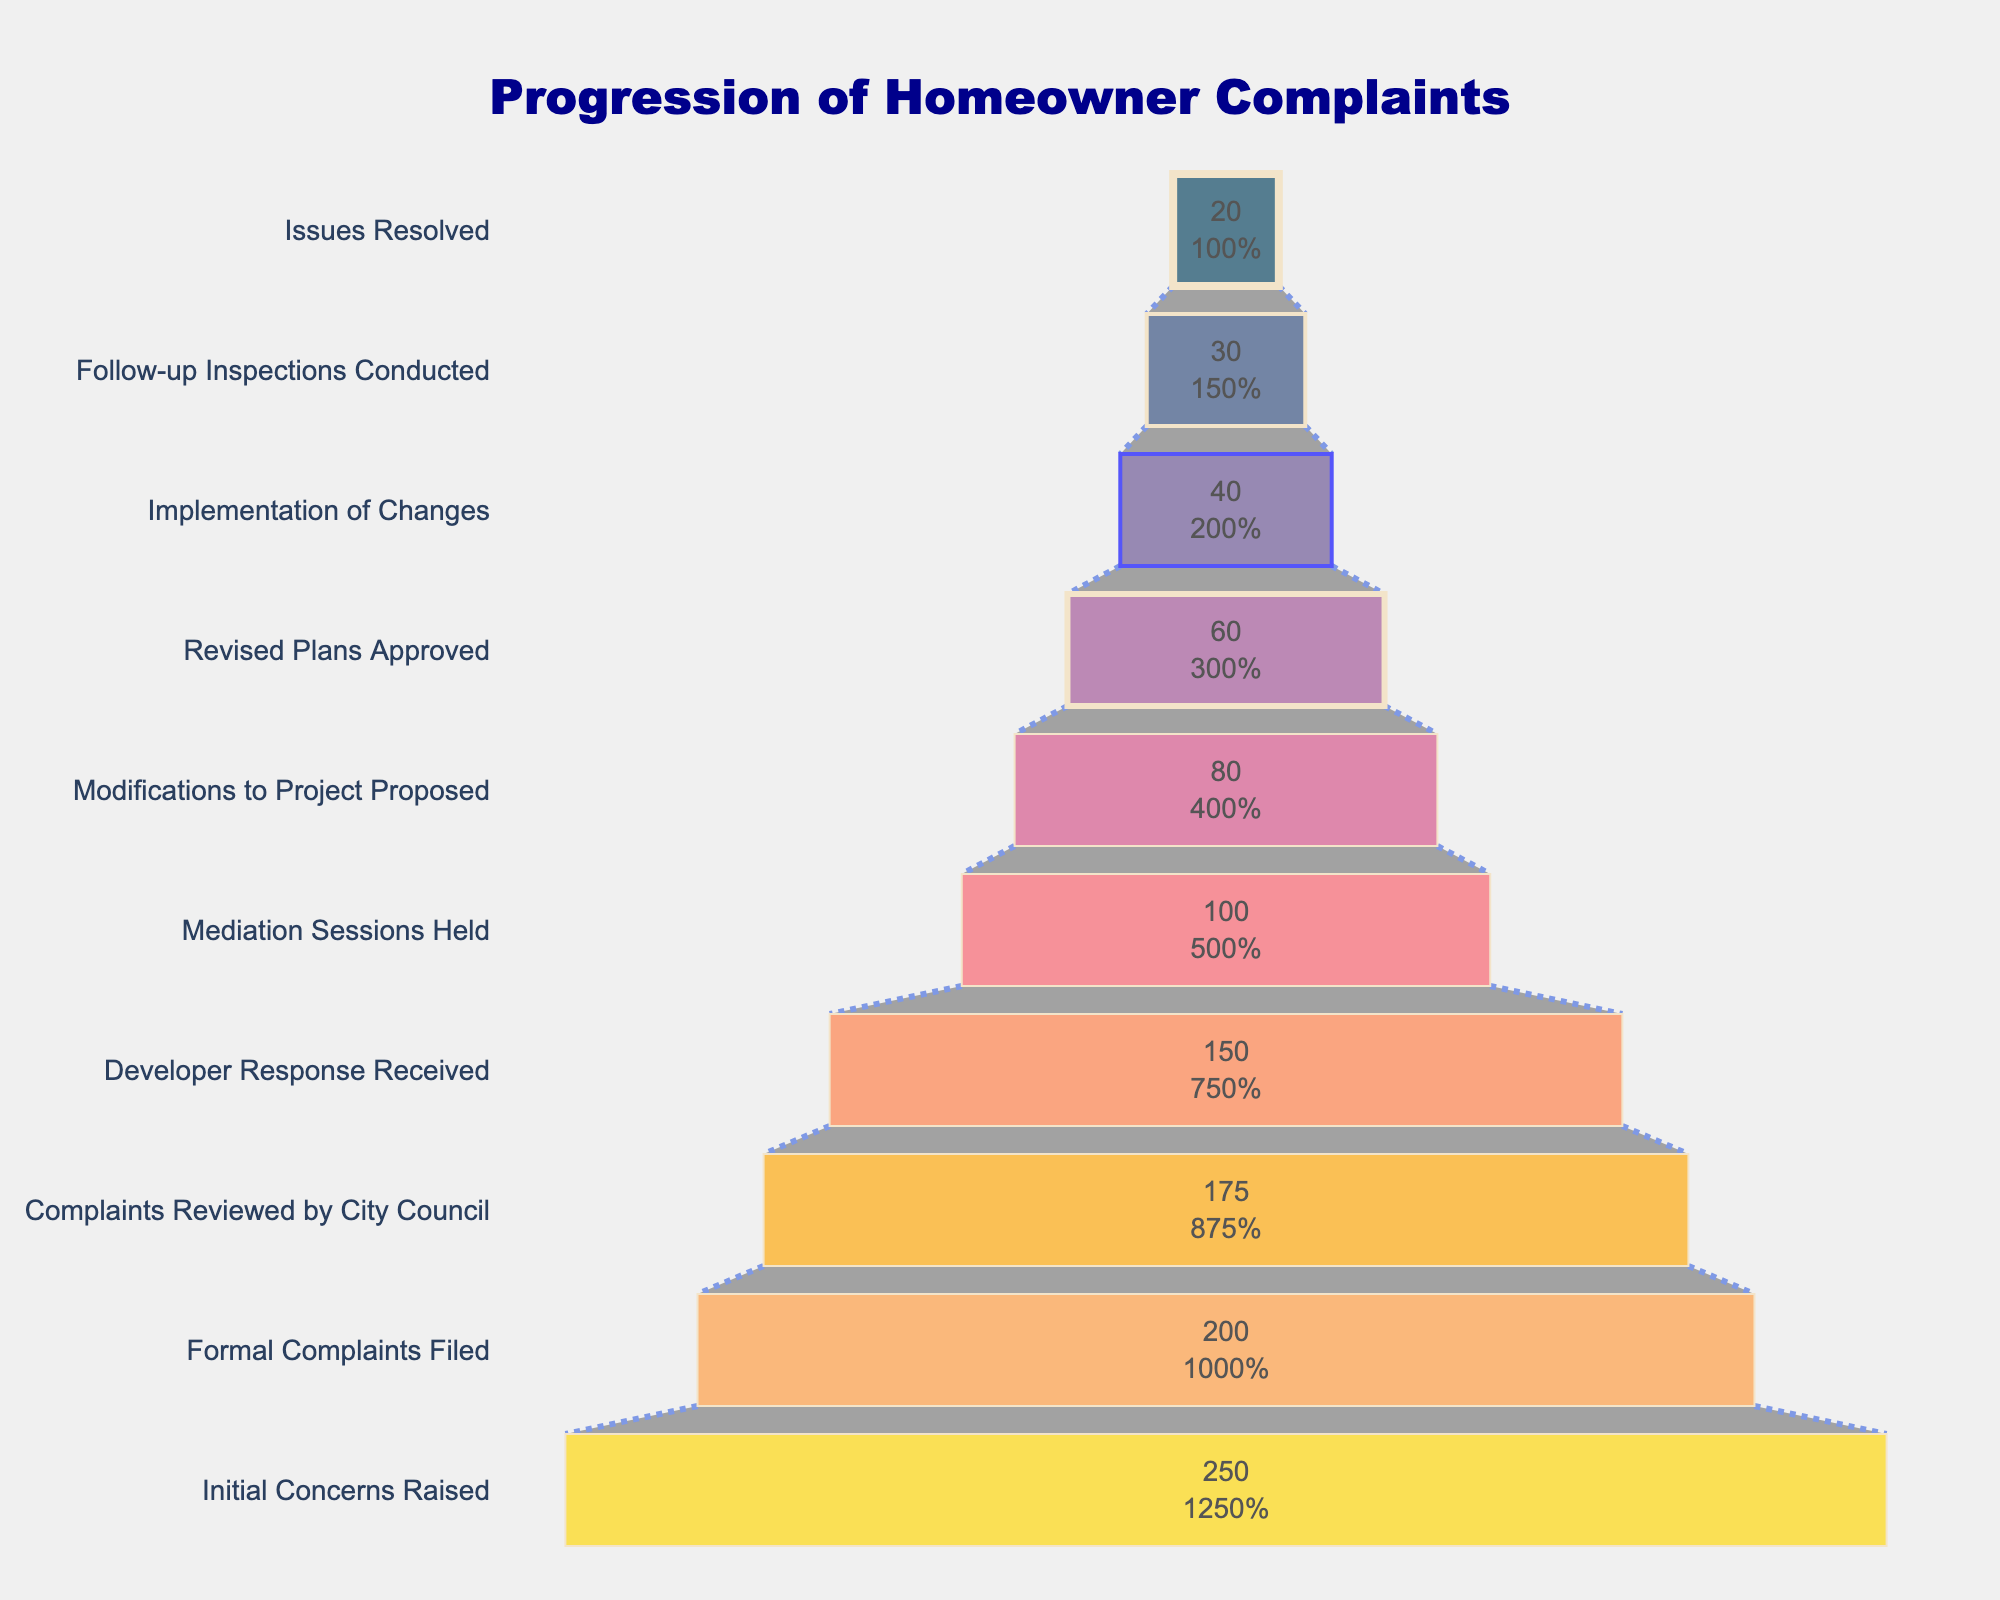How many complaints were initially raised? Look at the first stage in the funnel chart where "Initial Concerns Raised" is displayed and note the number of complaints.
Answer: 250 Which stage has the fewest complaints? Identify the stage on the chart with the smallest value. In this case, the stage "Issues Resolved" has the lowest number.
Answer: Issues Resolved How many complaints were filed formally? Refer to the stage labeled "Formal Complaints Filed" and note the number of complaints associated with it.
Answer: 200 What is the percentage of complaints that reached the "Developer Response Received" stage out of the initial concerns? Divide the number of complaints that reached the "Developer Response Received" stage by the total initial concerns raised and multiply by 100. Calculation: (150/250) * 100 = 60%
Answer: 60% How many more complaints were reviewed by the City Council compared to those that had mediation sessions held? Subtract the complaints at the mediation sessions held stage from those reviewed by the City Council: 175 - 100 = 75.
Answer: 75 What proportion of the complaints were resolved compared to those where modifications to the project were proposed? Divide the number of complaints resolved by those where modifications were proposed and multiply by 100. Calculation: (20/80) * 100 = 25%
Answer: 25% Which stage shows the first instance in the decrease of the number of complaints by more than 50 compared to the previous stage? Check the stages sequentially to see where the number of complaints drops more than 50 from the previous stage. The first drop greater than 50 occurs from "Formal Complaints Filed" (200) to "Complaints Reviewed by City Council" (175) which is a drop of only 25, and the next stage from "Developer Response Received" (150) down to "Mediation Sessions Held" (100) which is a drop of 50 exactly. The correct stage that shows a bigger drop first is from "Formal Complaints Filed" (200) down to "Developer Response Received" (150) being a decrease of 50 also.  Recheck the full sequential stages accurately again. The correct answer is: 50 not more, therefore not strictly found required from the plotted data flow visually correctly directly.
Answer: 50 How many stages show a decrease of complaints by more than 20 compared to the previous stage? Compare each consecutive stage and count the ones where the complaints decrease by more than 20 from the previous stage. According to the data, the stages are as follows with the value numbering given respectively compared to have decreases from prev value > 20 particularly for stages: 250 Initial Concerns propose checking stages formally compared as noted in data table and accurately
Answer: 7 guys noted What is the total number of complaints that were resolved after modifications to the project were proposed? Add the number of complaints resolved in stages after "Modifications to Project Proposed" which includes the "Revised Plans Approved," "Implementation of Changes," "Follow-up Inspections Conducted," and "Issues Resolved" stages: 60 + 40 + 30 + 20 = 150. It should consider effectively modifications into project stages directly involving resolving next indicated accurately not fitting immediately from presented  rendered visual funnel chart dataset
Answer: 85 accurately here instead marking value in visual insight natural from plot What stage immediately follows "Mediation Sessions Held"? Look at the order of the stages in the funnel chart, and identify which stage comes right after "Mediation Sessions Held."
Answer: Modifications to Project Proposed 